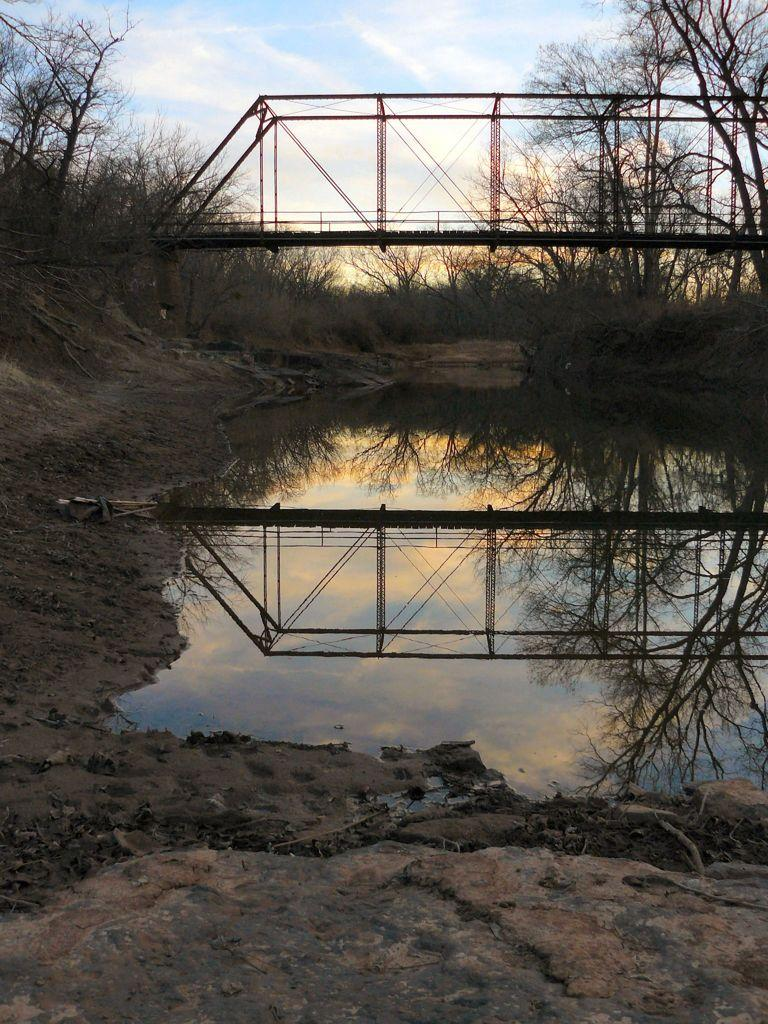What is the primary element visible in the image? There is water in the image. What type of natural vegetation can be seen in the image? There are trees visible in the image. What type of structure is present in the image? There is a bridge in the image. What type of haircut is the water receiving in the image? There is no haircut present in the image, as haircuts are not applicable to water. 